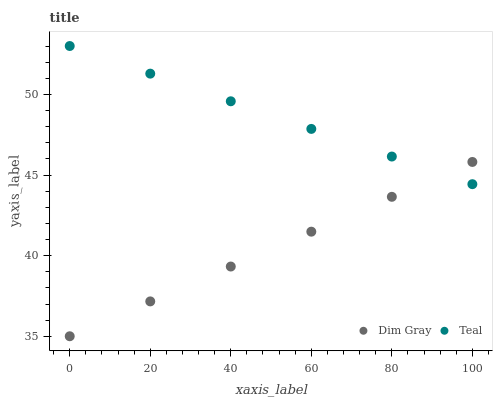Does Dim Gray have the minimum area under the curve?
Answer yes or no. Yes. Does Teal have the maximum area under the curve?
Answer yes or no. Yes. Does Teal have the minimum area under the curve?
Answer yes or no. No. Is Teal the smoothest?
Answer yes or no. Yes. Is Dim Gray the roughest?
Answer yes or no. Yes. Is Teal the roughest?
Answer yes or no. No. Does Dim Gray have the lowest value?
Answer yes or no. Yes. Does Teal have the lowest value?
Answer yes or no. No. Does Teal have the highest value?
Answer yes or no. Yes. Does Dim Gray intersect Teal?
Answer yes or no. Yes. Is Dim Gray less than Teal?
Answer yes or no. No. Is Dim Gray greater than Teal?
Answer yes or no. No. 